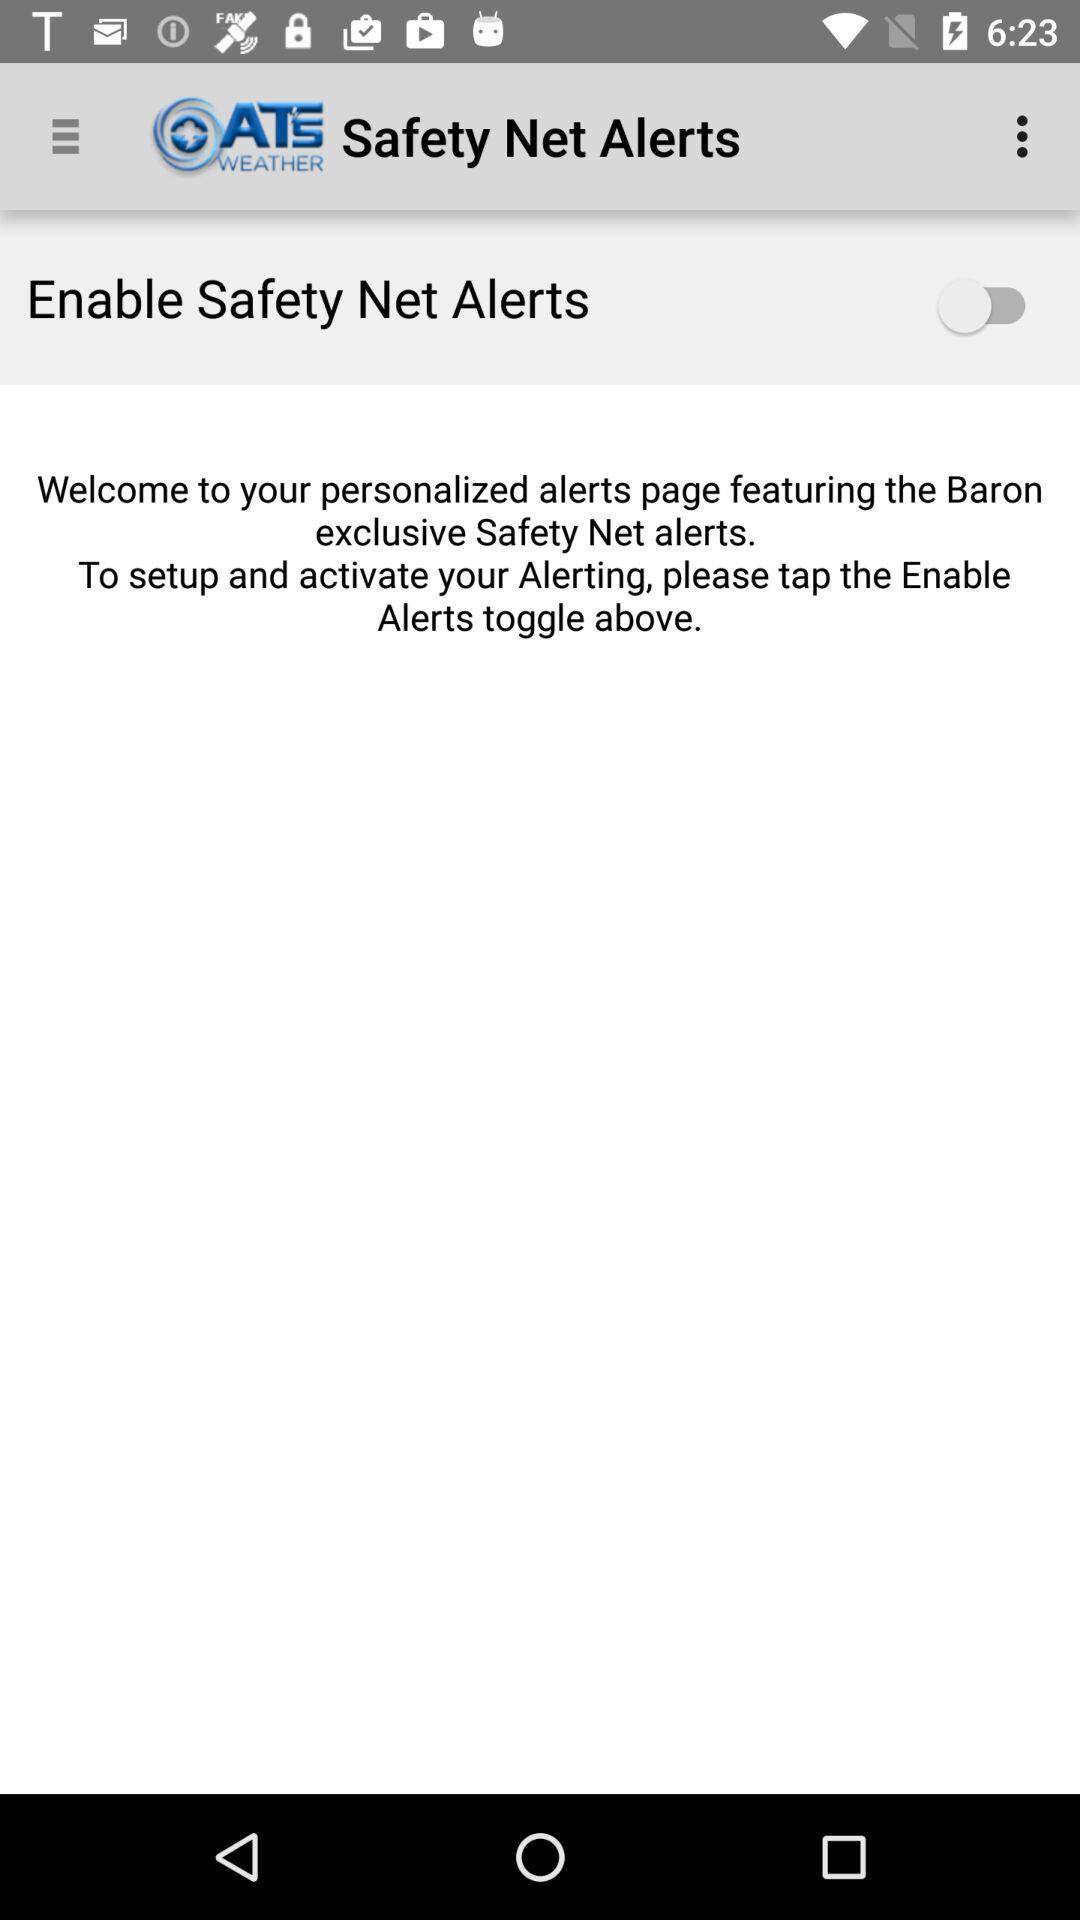What is the application name? The application name is "ATS WEATHER". 